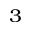Convert formula to latex. <formula><loc_0><loc_0><loc_500><loc_500>^ { 3 }</formula> 